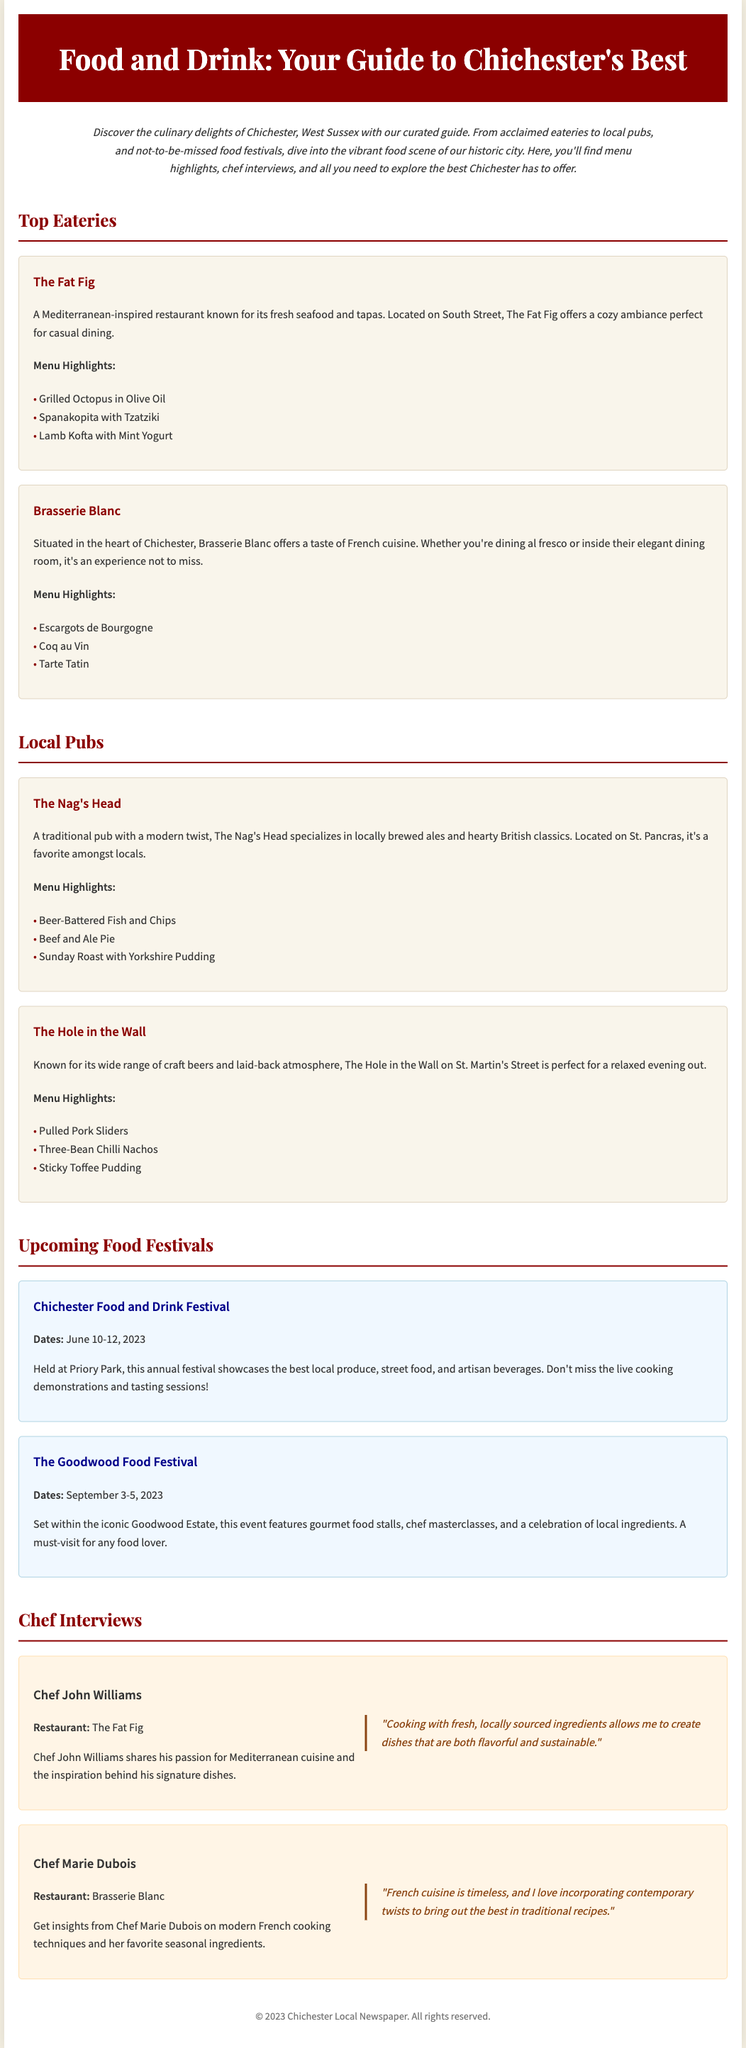What is the title of the guide? The title of the guide is prominently displayed in the header section of the document.
Answer: Food and Drink: Your Guide to Chichester's Best Where is The Fat Fig located? The location of The Fat Fig restaurant is mentioned in the description section.
Answer: South Street What are the dates for the Chichester Food and Drink Festival? The dates for the festival are specified in the festival section of the document.
Answer: June 10-12, 2023 Who is the chef at Brasserie Blanc? The chef at Brasserie Blanc is mentioned in the chef interview section.
Answer: Chef Marie Dubois What type of cuisine does The Nag's Head specialize in? The type of cuisine offered by The Nag's Head is discussed in the pub section of the document.
Answer: British classics What is one of the menu highlights at The Hole in the Wall? A specific menu highlight is listed under The Hole in the Wall's information.
Answer: Pulled Pork Sliders How many food festivals are mentioned in the guide? The total number of food festivals referenced in the document can be counted from the festival section.
Answer: Two What is Chef John Williams' restaurant? The restaurant associated with Chef John Williams is indicated in the chef interview section.
Answer: The Fat Fig What culinary theme is featured at the Goodwood Food Festival? The themed culinary experience of the Goodwood Food Festival is described.
Answer: local ingredients 